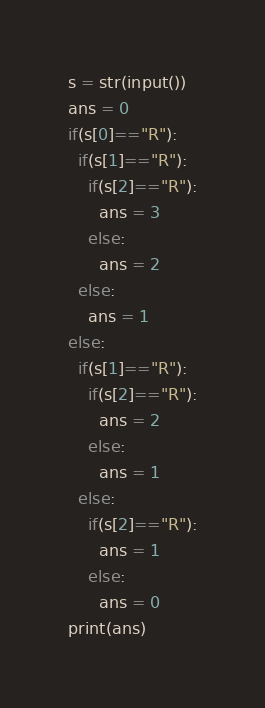Convert code to text. <code><loc_0><loc_0><loc_500><loc_500><_Python_>s = str(input())
ans = 0
if(s[0]=="R"):
  if(s[1]=="R"):
    if(s[2]=="R"):
      ans = 3
    else:
      ans = 2
  else:
    ans = 1
else:
  if(s[1]=="R"):
    if(s[2]=="R"):
      ans = 2
    else:
      ans = 1
  else:
    if(s[2]=="R"):
      ans = 1
    else:
      ans = 0
print(ans)
</code> 